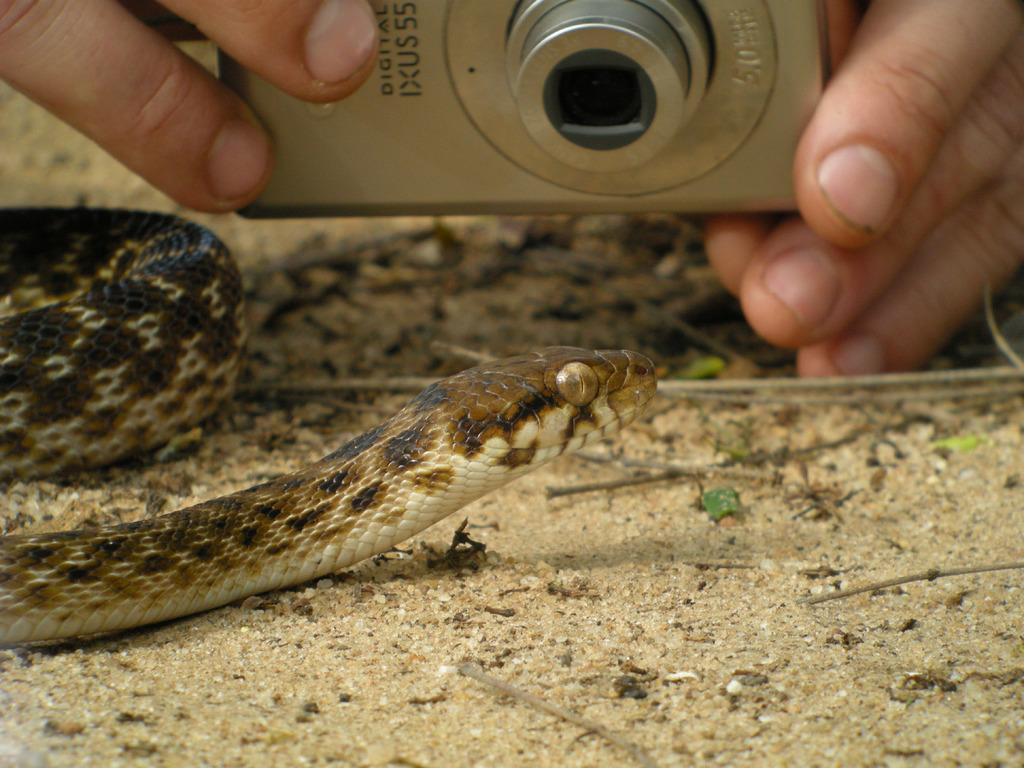What animal is present in the image? There is a snake in the image. What colors can be seen on the snake? The snake has white, black, and brown colors. Can you describe the person in the background of the image? There is a person holding a camera in the background of the image. What type of knee can be seen on the edge of the image? There is no knee present in the image; it features a snake and a person holding a camera. 